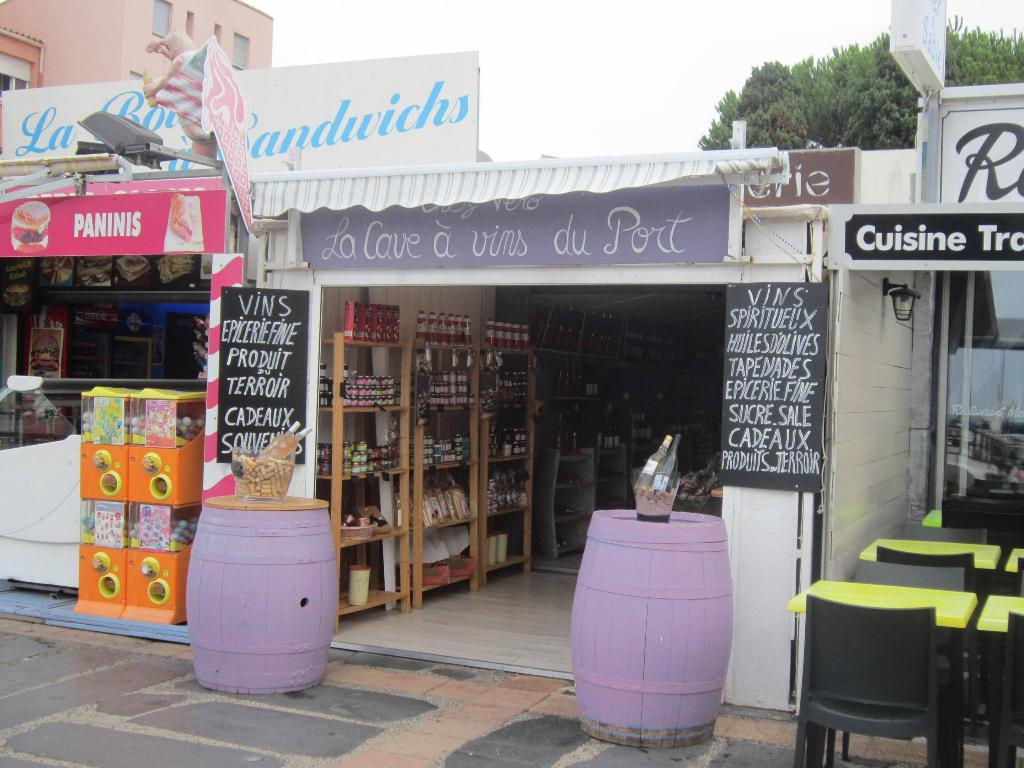What type of furniture can be seen in the image? There are tables and chairs in the image. What musical instruments are present in the image? There are drums in the image. What items are placed in bowls in the image? There are bottles in bowls in the image. What objects are used for identification in the image? There are name boards in the image. What decorative elements are present in the image? There are banners in the image. What storage units are visible in the image? There are racks in the image. What type of structure is visible in the image? There is a building with windows in the image. What type of natural elements can be seen in the image? There are trees in the image. What can be seen in the background of the image? The sky is visible in the background of the image. Can you see a zephyr blowing through the trees in the image? There is no mention of a zephyr in the image, and it is not visible. What type of cart is being used to transport the drums in the image? There is no cart present in the image; the drums are stationary. 